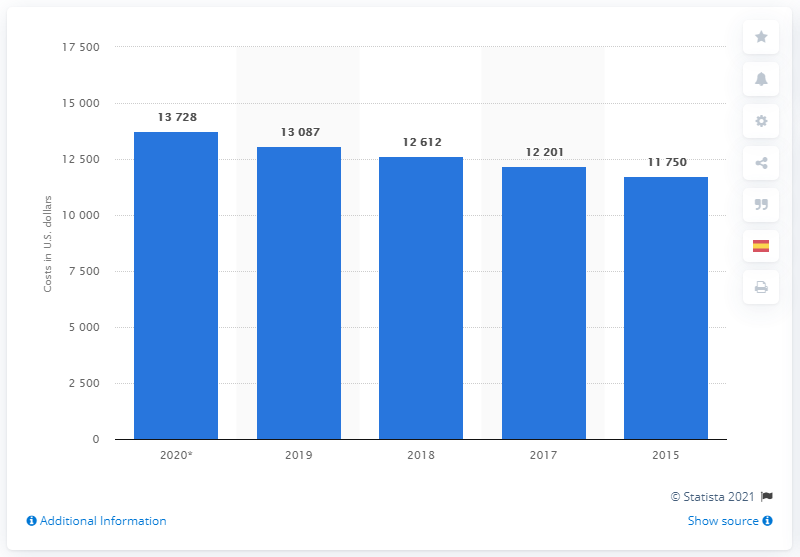List a handful of essential elements in this visual. According to estimates, the annual cost of health care for employees in the United States is projected to reach approximately 13,728 by 2020. As of 2019, the total annual medical costs for employees were approximately 13,087. 